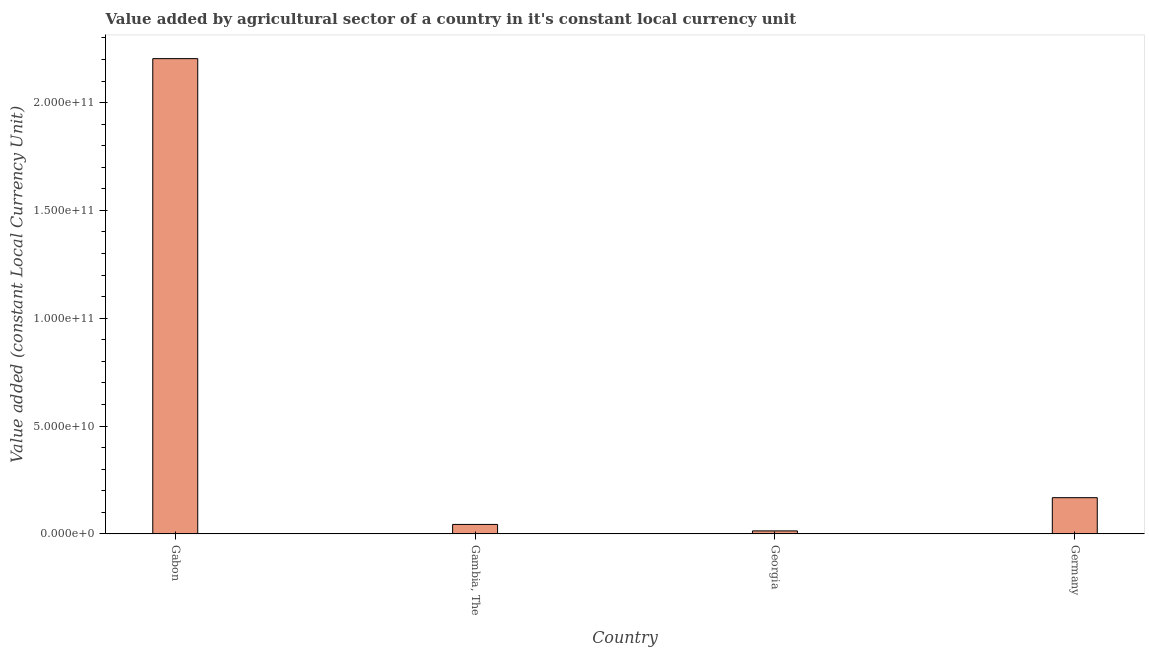Does the graph contain any zero values?
Provide a short and direct response. No. What is the title of the graph?
Your response must be concise. Value added by agricultural sector of a country in it's constant local currency unit. What is the label or title of the X-axis?
Keep it short and to the point. Country. What is the label or title of the Y-axis?
Offer a very short reply. Value added (constant Local Currency Unit). What is the value added by agriculture sector in Gambia, The?
Offer a very short reply. 4.37e+09. Across all countries, what is the maximum value added by agriculture sector?
Your response must be concise. 2.20e+11. Across all countries, what is the minimum value added by agriculture sector?
Offer a very short reply. 1.38e+09. In which country was the value added by agriculture sector maximum?
Offer a very short reply. Gabon. In which country was the value added by agriculture sector minimum?
Keep it short and to the point. Georgia. What is the sum of the value added by agriculture sector?
Your answer should be compact. 2.43e+11. What is the difference between the value added by agriculture sector in Gabon and Georgia?
Your answer should be very brief. 2.19e+11. What is the average value added by agriculture sector per country?
Ensure brevity in your answer.  6.07e+1. What is the median value added by agriculture sector?
Keep it short and to the point. 1.06e+1. What is the ratio of the value added by agriculture sector in Gambia, The to that in Georgia?
Your answer should be compact. 3.18. Is the value added by agriculture sector in Gambia, The less than that in Germany?
Make the answer very short. Yes. Is the difference between the value added by agriculture sector in Gabon and Gambia, The greater than the difference between any two countries?
Offer a terse response. No. What is the difference between the highest and the second highest value added by agriculture sector?
Offer a very short reply. 2.04e+11. Is the sum of the value added by agriculture sector in Gambia, The and Georgia greater than the maximum value added by agriculture sector across all countries?
Offer a very short reply. No. What is the difference between the highest and the lowest value added by agriculture sector?
Your response must be concise. 2.19e+11. In how many countries, is the value added by agriculture sector greater than the average value added by agriculture sector taken over all countries?
Offer a very short reply. 1. Are all the bars in the graph horizontal?
Provide a succinct answer. No. Are the values on the major ticks of Y-axis written in scientific E-notation?
Ensure brevity in your answer.  Yes. What is the Value added (constant Local Currency Unit) in Gabon?
Your response must be concise. 2.20e+11. What is the Value added (constant Local Currency Unit) in Gambia, The?
Offer a terse response. 4.37e+09. What is the Value added (constant Local Currency Unit) of Georgia?
Give a very brief answer. 1.38e+09. What is the Value added (constant Local Currency Unit) in Germany?
Provide a succinct answer. 1.68e+1. What is the difference between the Value added (constant Local Currency Unit) in Gabon and Gambia, The?
Give a very brief answer. 2.16e+11. What is the difference between the Value added (constant Local Currency Unit) in Gabon and Georgia?
Your answer should be compact. 2.19e+11. What is the difference between the Value added (constant Local Currency Unit) in Gabon and Germany?
Your response must be concise. 2.04e+11. What is the difference between the Value added (constant Local Currency Unit) in Gambia, The and Georgia?
Your answer should be very brief. 3.00e+09. What is the difference between the Value added (constant Local Currency Unit) in Gambia, The and Germany?
Your answer should be compact. -1.24e+1. What is the difference between the Value added (constant Local Currency Unit) in Georgia and Germany?
Keep it short and to the point. -1.54e+1. What is the ratio of the Value added (constant Local Currency Unit) in Gabon to that in Gambia, The?
Make the answer very short. 50.38. What is the ratio of the Value added (constant Local Currency Unit) in Gabon to that in Georgia?
Keep it short and to the point. 160.01. What is the ratio of the Value added (constant Local Currency Unit) in Gabon to that in Germany?
Make the answer very short. 13.13. What is the ratio of the Value added (constant Local Currency Unit) in Gambia, The to that in Georgia?
Give a very brief answer. 3.18. What is the ratio of the Value added (constant Local Currency Unit) in Gambia, The to that in Germany?
Your answer should be very brief. 0.26. What is the ratio of the Value added (constant Local Currency Unit) in Georgia to that in Germany?
Your answer should be compact. 0.08. 